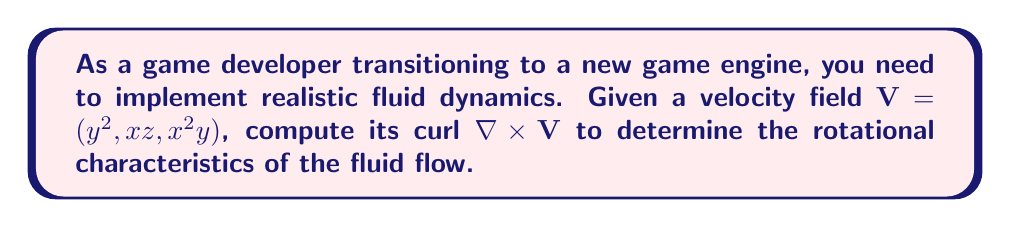Could you help me with this problem? To compute the curl of the velocity field, we'll follow these steps:

1) The curl of a vector field $\mathbf{V} = (V_x, V_y, V_z)$ is defined as:

   $$\nabla \times \mathbf{V} = \left(\frac{\partial V_z}{\partial y} - \frac{\partial V_y}{\partial z}, \frac{\partial V_x}{\partial z} - \frac{\partial V_z}{\partial x}, \frac{\partial V_y}{\partial x} - \frac{\partial V_x}{\partial y}\right)$$

2) For our velocity field $\mathbf{V} = (y^2, xz, x^2y)$, we have:
   $V_x = y^2$, $V_y = xz$, $V_z = x^2y$

3) Let's compute each component:

   a) $\frac{\partial V_z}{\partial y} - \frac{\partial V_y}{\partial z}$:
      $\frac{\partial V_z}{\partial y} = \frac{\partial (x^2y)}{\partial y} = x^2$
      $\frac{\partial V_y}{\partial z} = \frac{\partial (xz)}{\partial z} = x$
      First component: $x^2 - x = x(x-1)$

   b) $\frac{\partial V_x}{\partial z} - \frac{\partial V_z}{\partial x}$:
      $\frac{\partial V_x}{\partial z} = \frac{\partial (y^2)}{\partial z} = 0$
      $\frac{\partial V_z}{\partial x} = \frac{\partial (x^2y)}{\partial x} = 2xy$
      Second component: $0 - 2xy = -2xy$

   c) $\frac{\partial V_y}{\partial x} - \frac{\partial V_x}{\partial y}$:
      $\frac{\partial V_y}{\partial x} = \frac{\partial (xz)}{\partial x} = z$
      $\frac{\partial V_x}{\partial y} = \frac{\partial (y^2)}{\partial y} = 2y$
      Third component: $z - 2y$

4) Combining these components, we get:

   $$\nabla \times \mathbf{V} = (x(x-1), -2xy, z-2y)$$

This curl vector field describes the rotational characteristics of the fluid flow in your game engine.
Answer: $(x(x-1), -2xy, z-2y)$ 